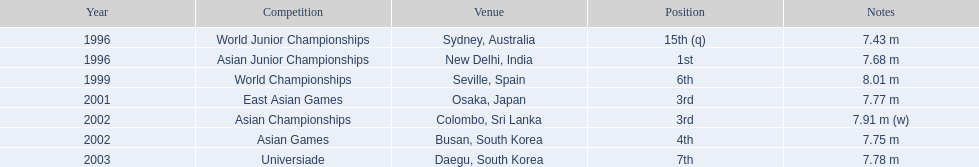What placements has this contender reached during the events? 15th (q), 1st, 6th, 3rd, 3rd, 4th, 7th. In which event did the contender win 1st place? Asian Junior Championships. 